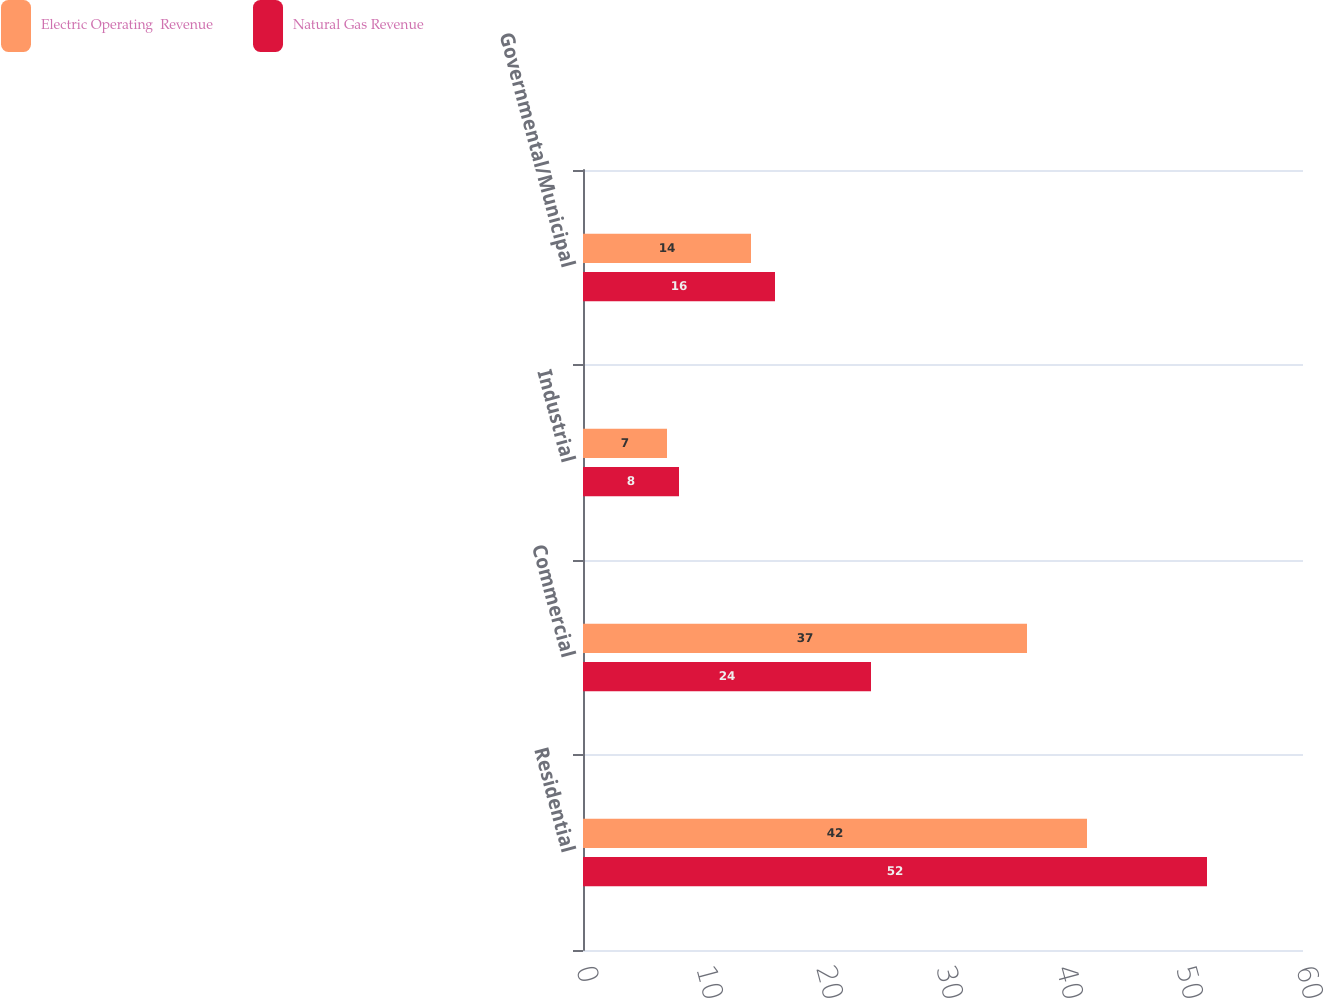Convert chart. <chart><loc_0><loc_0><loc_500><loc_500><stacked_bar_chart><ecel><fcel>Residential<fcel>Commercial<fcel>Industrial<fcel>Governmental/Municipal<nl><fcel>Electric Operating  Revenue<fcel>42<fcel>37<fcel>7<fcel>14<nl><fcel>Natural Gas Revenue<fcel>52<fcel>24<fcel>8<fcel>16<nl></chart> 